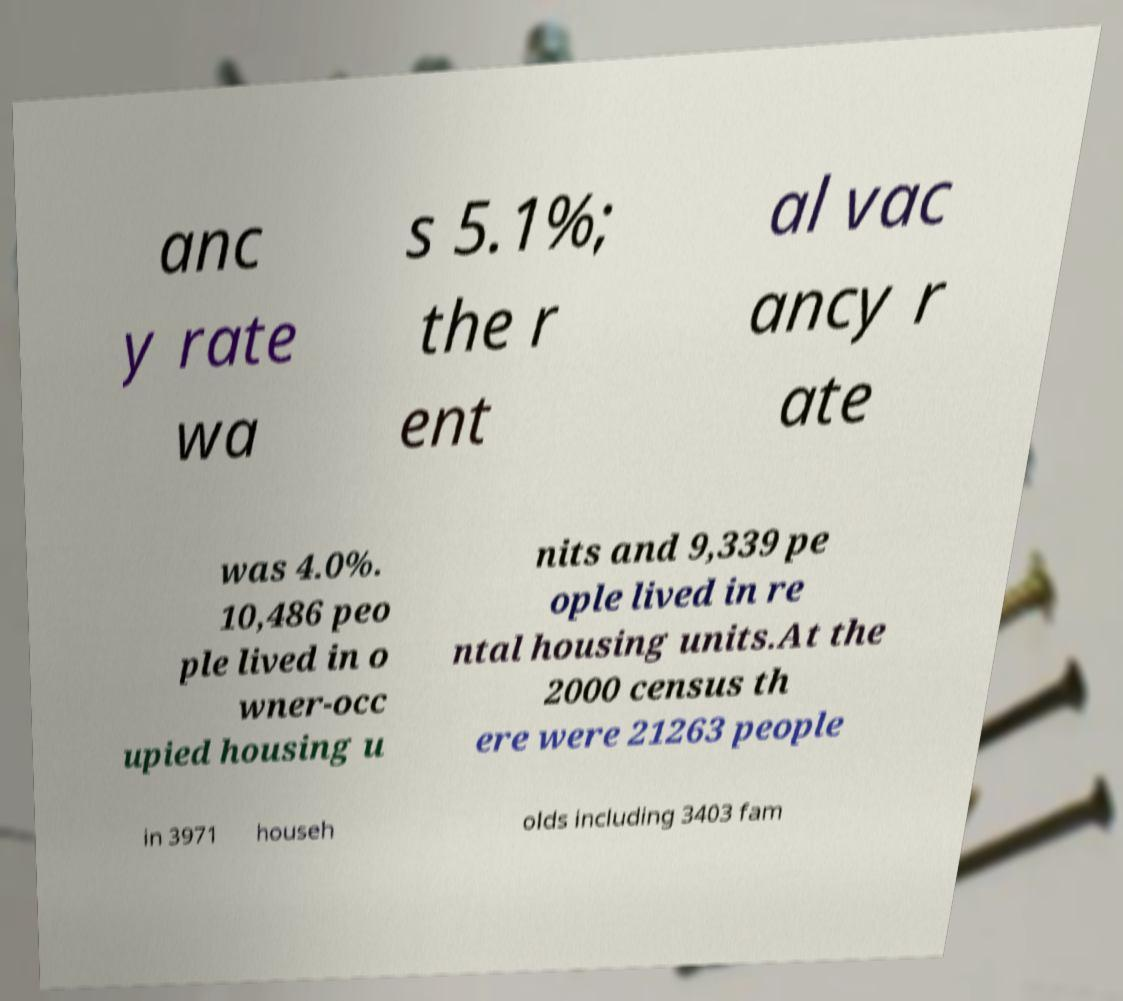Could you extract and type out the text from this image? anc y rate wa s 5.1%; the r ent al vac ancy r ate was 4.0%. 10,486 peo ple lived in o wner-occ upied housing u nits and 9,339 pe ople lived in re ntal housing units.At the 2000 census th ere were 21263 people in 3971 househ olds including 3403 fam 